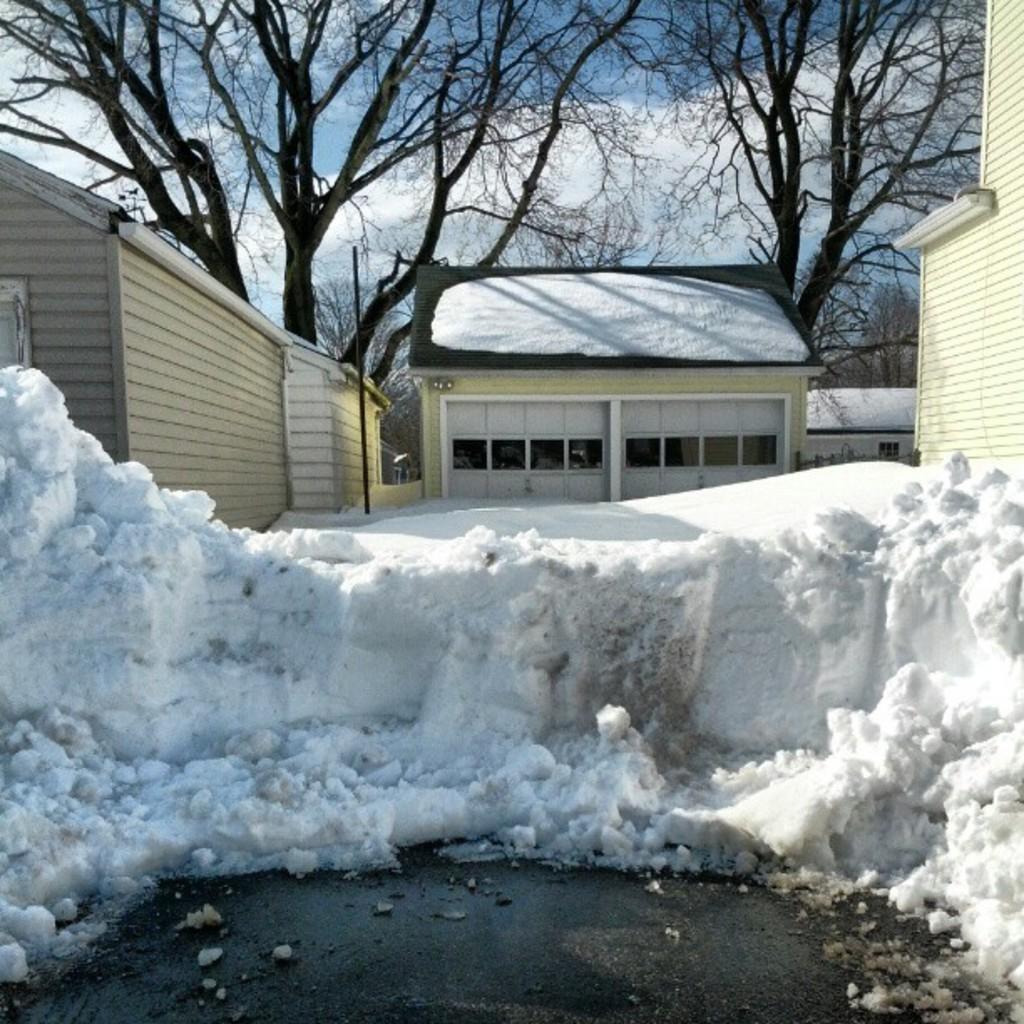In one or two sentences, can you explain what this image depicts? In this picture we can see houses with windows, pole, snow, trees and in the background we can see the sky with clouds. 